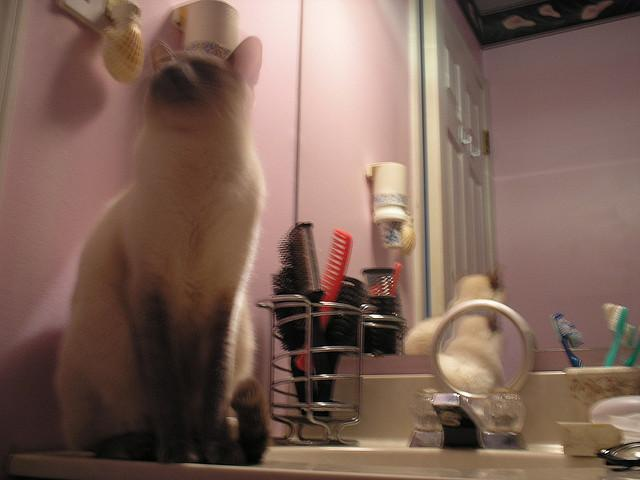What is the red item inside the holder? Please explain your reasoning. comb. It has one row of plastic teeth. 